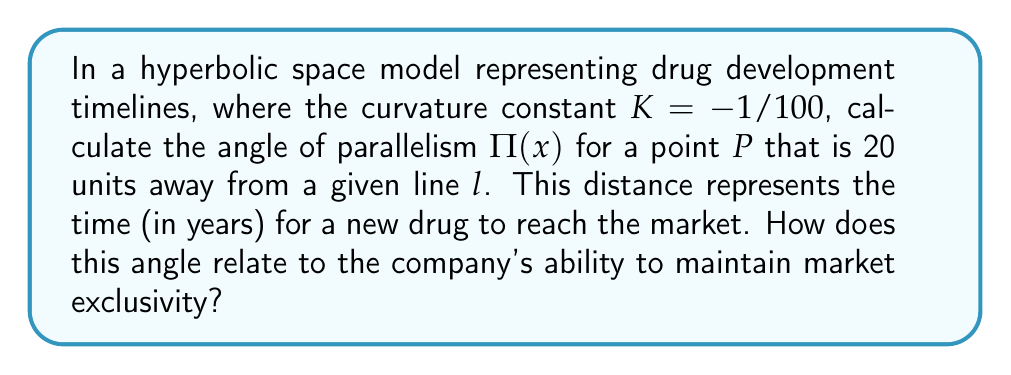Solve this math problem. To solve this problem, we'll follow these steps:

1) In hyperbolic geometry, the angle of parallelism $\Pi(x)$ is given by the formula:

   $$\Pi(x) = 2 \arctan(e^{-x\sqrt{-K}})$$

   where $x$ is the distance from the point to the line, and $K$ is the curvature constant.

2) We're given that $K = -1/100$ and $x = 20$. Let's substitute these values:

   $$\Pi(20) = 2 \arctan(e^{-20\sqrt{1/100}})$$

3) Simplify the expression under the square root:
   
   $$\Pi(20) = 2 \arctan(e^{-20/10}) = 2 \arctan(e^{-2})$$

4) Calculate $e^{-2}$:
   
   $$\Pi(20) = 2 \arctan(0.1353)$$

5) Use a calculator to evaluate $\arctan(0.1353)$:
   
   $$\Pi(20) = 2 * 0.1345 = 0.2690 \text{ radians}$$

6) Convert to degrees:
   
   $$\Pi(20) = 0.2690 * \frac{180}{\pi} \approx 15.41°$$

This angle represents the maximum angle at which a line through P can be drawn without intersecting the given line l. In the context of drug development, a smaller angle of parallelism indicates a longer effective period of market exclusivity. The 15.41° angle suggests a relatively long period of exclusivity, aligning with the pharmaceutical executive's desire to maintain strong patent protection.
Answer: $\Pi(20) \approx 15.41°$ 